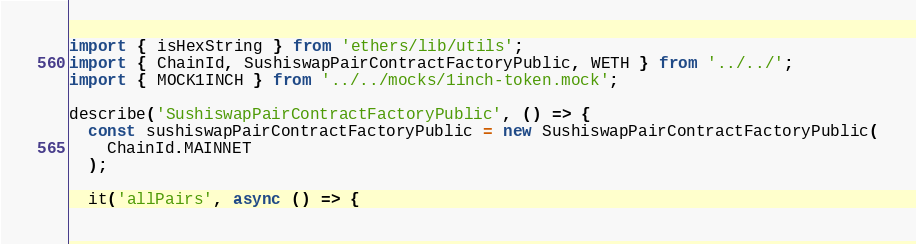Convert code to text. <code><loc_0><loc_0><loc_500><loc_500><_TypeScript_>import { isHexString } from 'ethers/lib/utils';
import { ChainId, SushiswapPairContractFactoryPublic, WETH } from '../../';
import { MOCK1INCH } from '../../mocks/1inch-token.mock';

describe('SushiswapPairContractFactoryPublic', () => {
  const sushiswapPairContractFactoryPublic = new SushiswapPairContractFactoryPublic(
    ChainId.MAINNET
  );

  it('allPairs', async () => {</code> 